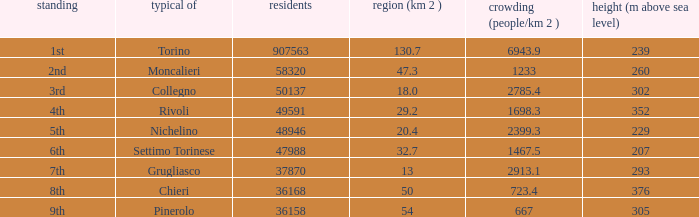What is the ranking of a common with a 47.3 km^2 area? 2nd. 